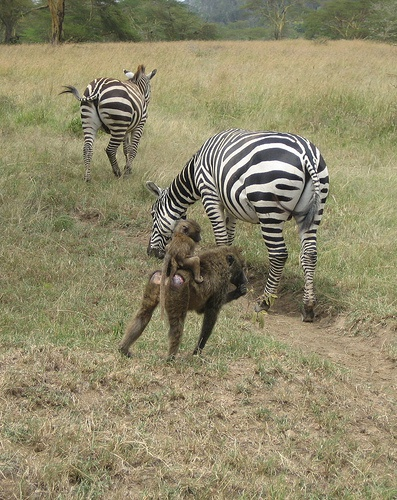Describe the objects in this image and their specific colors. I can see zebra in darkgreen, gray, black, darkgray, and ivory tones, zebra in darkgreen, gray, darkgray, and black tones, and bird in darkgreen, lightgray, gray, and darkgray tones in this image. 